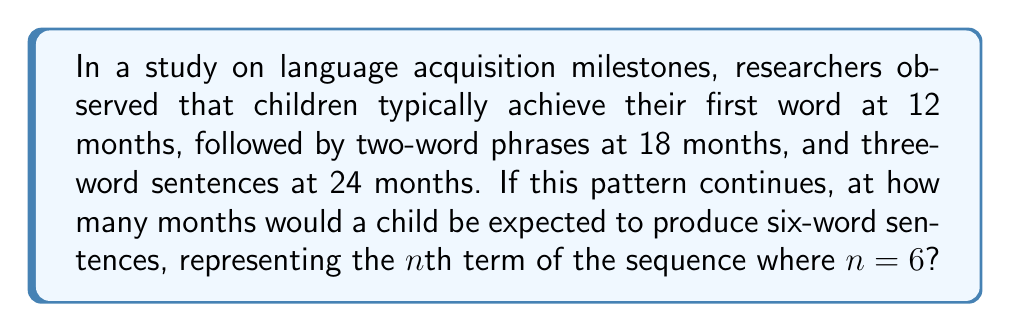Help me with this question. Let's approach this step-by-step:

1) First, let's identify the pattern in the given information:
   - 1 word at 12 months
   - 2 words at 18 months
   - 3 words at 24 months

2) We can express this as a sequence where the nth term represents the number of words, and the corresponding value represents the number of months:

   $a_1 = 12$ (1 word at 12 months)
   $a_2 = 18$ (2 words at 18 months)
   $a_3 = 24$ (3 words at 24 months)

3) To find the general term, let's look at the differences between consecutive terms:
   $a_2 - a_1 = 18 - 12 = 6$
   $a_3 - a_2 = 24 - 18 = 6$

4) We can see that the difference is constant (6 months). This suggests an arithmetic sequence with a common difference of 6.

5) The general term for an arithmetic sequence is given by:
   $a_n = a_1 + (n-1)d$
   Where $a_1$ is the first term, $n$ is the position, and $d$ is the common difference.

6) In this case:
   $a_1 = 12$
   $d = 6$

7) Therefore, the general term is:
   $a_n = 12 + (n-1)6$
   $a_n = 12 + 6n - 6$
   $a_n = 6n + 6$

8) We're asked about 6-word sentences, so $n = 6$:
   $a_6 = 6(6) + 6 = 36 + 6 = 42$

Therefore, a child would be expected to produce six-word sentences at 42 months.
Answer: 42 months 